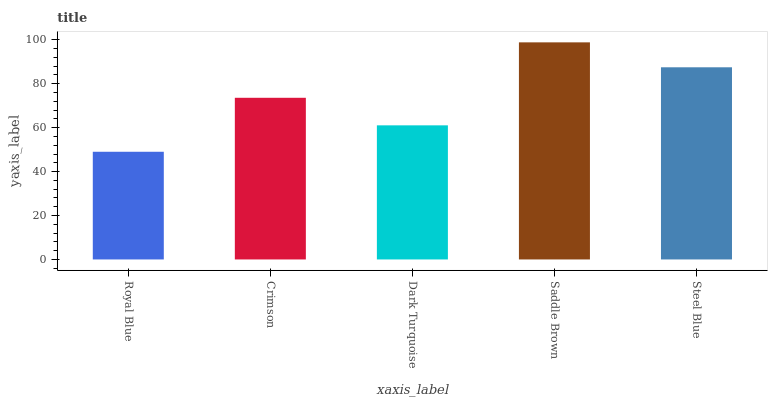Is Royal Blue the minimum?
Answer yes or no. Yes. Is Saddle Brown the maximum?
Answer yes or no. Yes. Is Crimson the minimum?
Answer yes or no. No. Is Crimson the maximum?
Answer yes or no. No. Is Crimson greater than Royal Blue?
Answer yes or no. Yes. Is Royal Blue less than Crimson?
Answer yes or no. Yes. Is Royal Blue greater than Crimson?
Answer yes or no. No. Is Crimson less than Royal Blue?
Answer yes or no. No. Is Crimson the high median?
Answer yes or no. Yes. Is Crimson the low median?
Answer yes or no. Yes. Is Steel Blue the high median?
Answer yes or no. No. Is Steel Blue the low median?
Answer yes or no. No. 